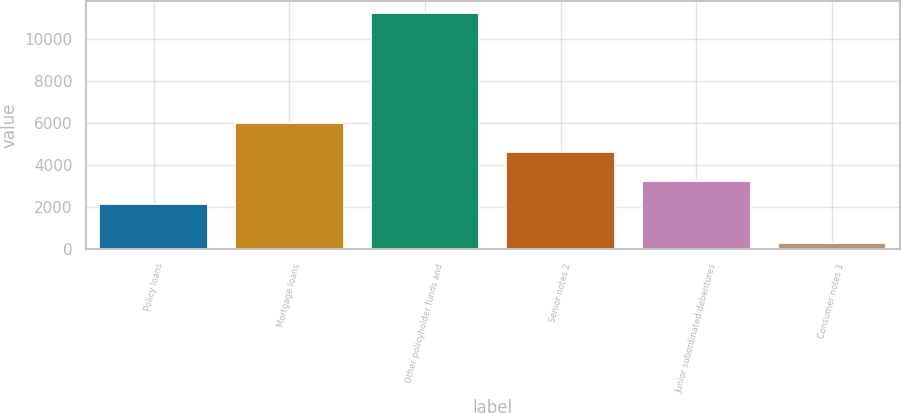<chart> <loc_0><loc_0><loc_500><loc_500><bar_chart><fcel>Policy loans<fcel>Mortgage loans<fcel>Other policyholder funds and<fcel>Senior notes 2<fcel>Junior subordinated debentures<fcel>Consumer notes 3<nl><fcel>2153<fcel>5977<fcel>11238<fcel>4623<fcel>3246.3<fcel>305<nl></chart> 